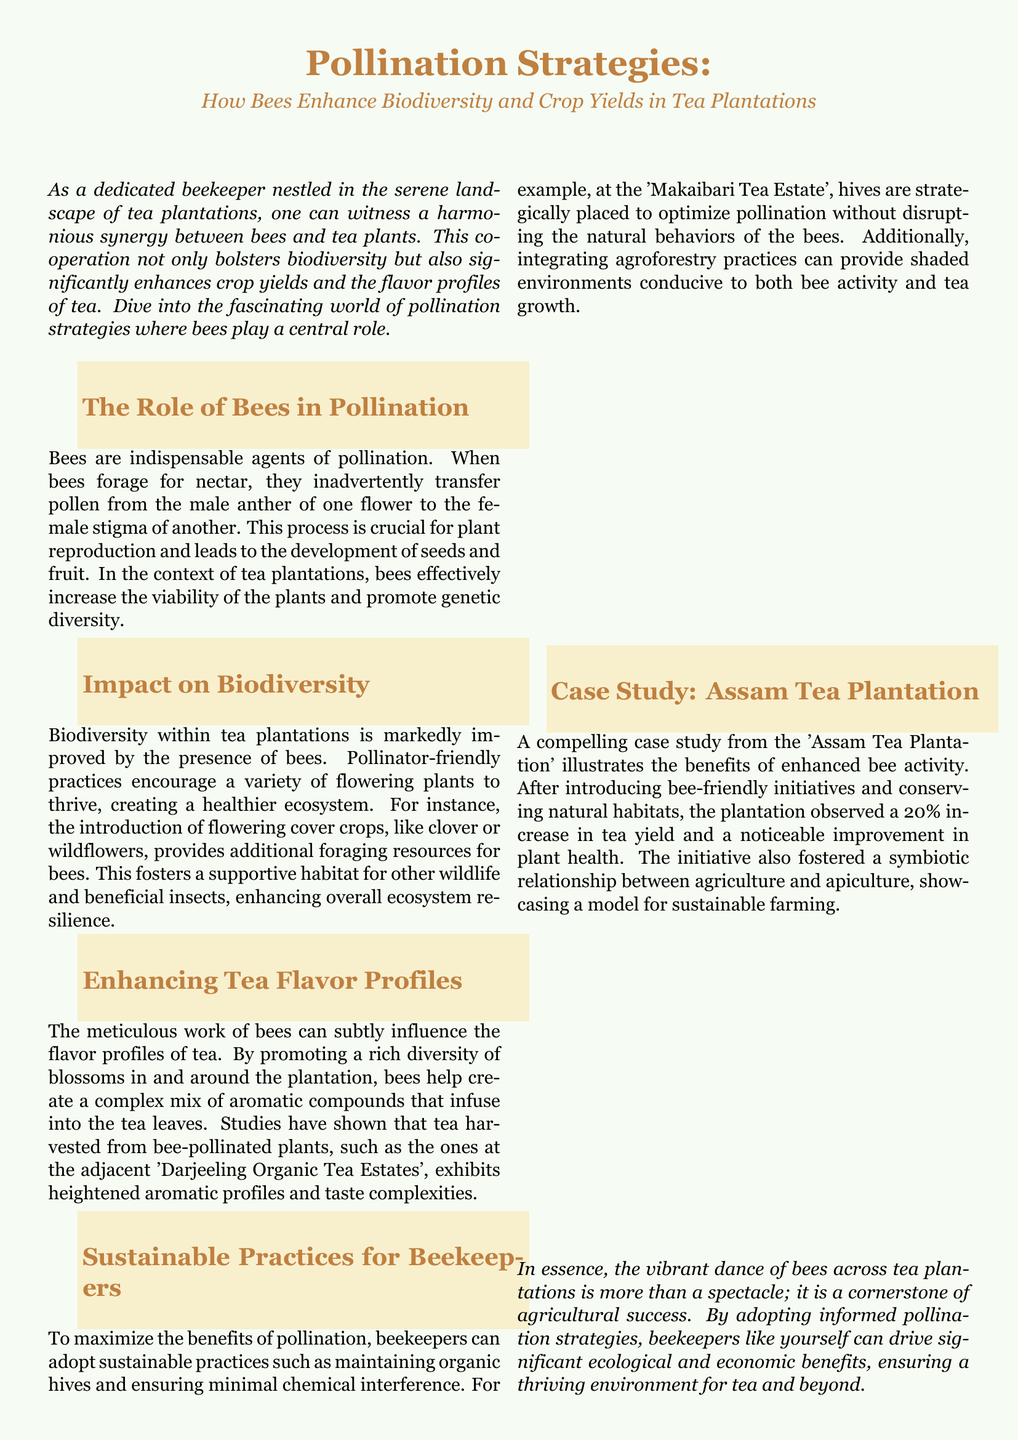What is the title of the document? The title provides an overview of the main topic discussed in the document, which is "Pollination Strategies: How Bees Enhance Biodiversity and Crop Yields in Tea Plantations."
Answer: Pollination Strategies: How Bees Enhance Biodiversity and Crop Yields in Tea Plantations What is one pollinator-friendly practice mentioned? The document lists the introduction of flowering cover crops as a pollinator-friendly practice that enhances biodiversity in tea plantations.
Answer: Flowering cover crops What was the percentage increase in tea yield observed at the Assam Tea Plantation? The increase in tea yield after implementing bee-friendly initiatives at the Assam Tea Plantation was quantified as a percentage.
Answer: 20% Which tea estate is cited for maintaining beehives to optimize pollination? The document specifically mentions the 'Makaibari Tea Estate' as a place where beekeepers strategically place hives to enhance pollination.
Answer: Makaibari Tea Estate How do bees affect the flavor profiles of tea? The document explains that bees promote a rich diversity of blossoms that contribute to the complex mix of aromatic compounds in tea, influencing its flavor.
Answer: Complex mix of aromatic compounds What type of document is this? The layout and content indicate that this is a magazine document, written with an informative purpose targeting beekeepers and tea plantation owners.
Answer: Magazine layout How do bees contribute to genetic diversity in tea plants? The process of transferring pollen between flowers done by bees is crucial for plant reproduction and enhances genetic variation within the tea plants.
Answer: Transfer pollen What is one benefit of biodiversity within tea plantations? The document suggests that improved biodiversity encourages a variety of flowering plants, creating a healthier ecosystem in the tea plantations.
Answer: Healthier ecosystem 